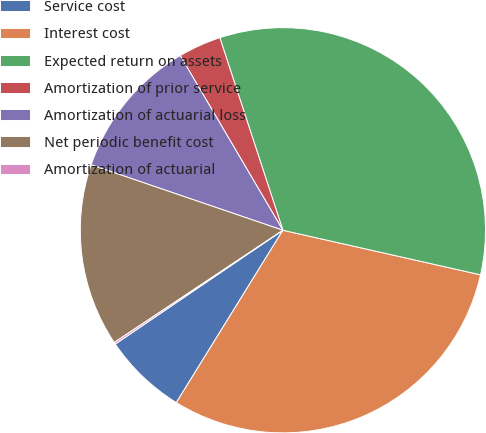Convert chart to OTSL. <chart><loc_0><loc_0><loc_500><loc_500><pie_chart><fcel>Service cost<fcel>Interest cost<fcel>Expected return on assets<fcel>Amortization of prior service<fcel>Amortization of actuarial loss<fcel>Net periodic benefit cost<fcel>Amortization of actuarial<nl><fcel>6.69%<fcel>30.29%<fcel>33.57%<fcel>3.42%<fcel>11.31%<fcel>14.58%<fcel>0.15%<nl></chart> 